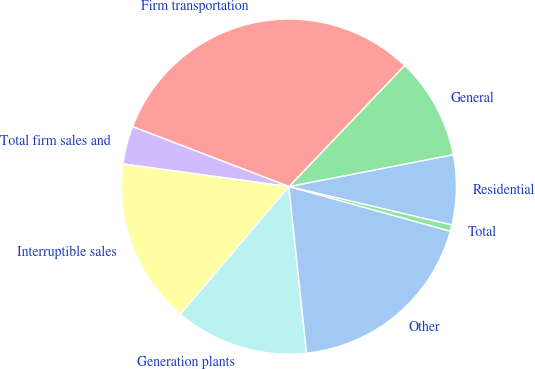Convert chart to OTSL. <chart><loc_0><loc_0><loc_500><loc_500><pie_chart><fcel>Residential<fcel>General<fcel>Firm transportation<fcel>Total firm sales and<fcel>Interruptible sales<fcel>Generation plants<fcel>Other<fcel>Total<nl><fcel>6.74%<fcel>9.81%<fcel>31.31%<fcel>3.67%<fcel>15.95%<fcel>12.88%<fcel>19.03%<fcel>0.6%<nl></chart> 